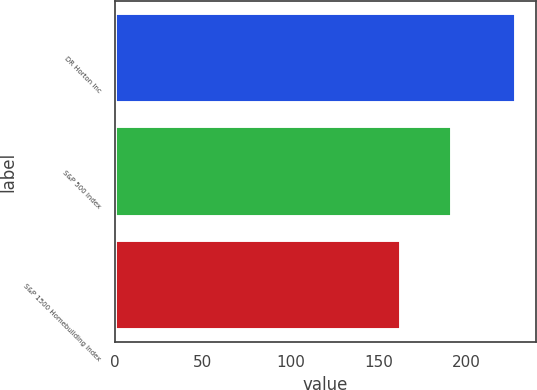<chart> <loc_0><loc_0><loc_500><loc_500><bar_chart><fcel>DR Horton Inc<fcel>S&P 500 Index<fcel>S&P 1500 Homebuilding Index<nl><fcel>228.09<fcel>192.1<fcel>162.82<nl></chart> 